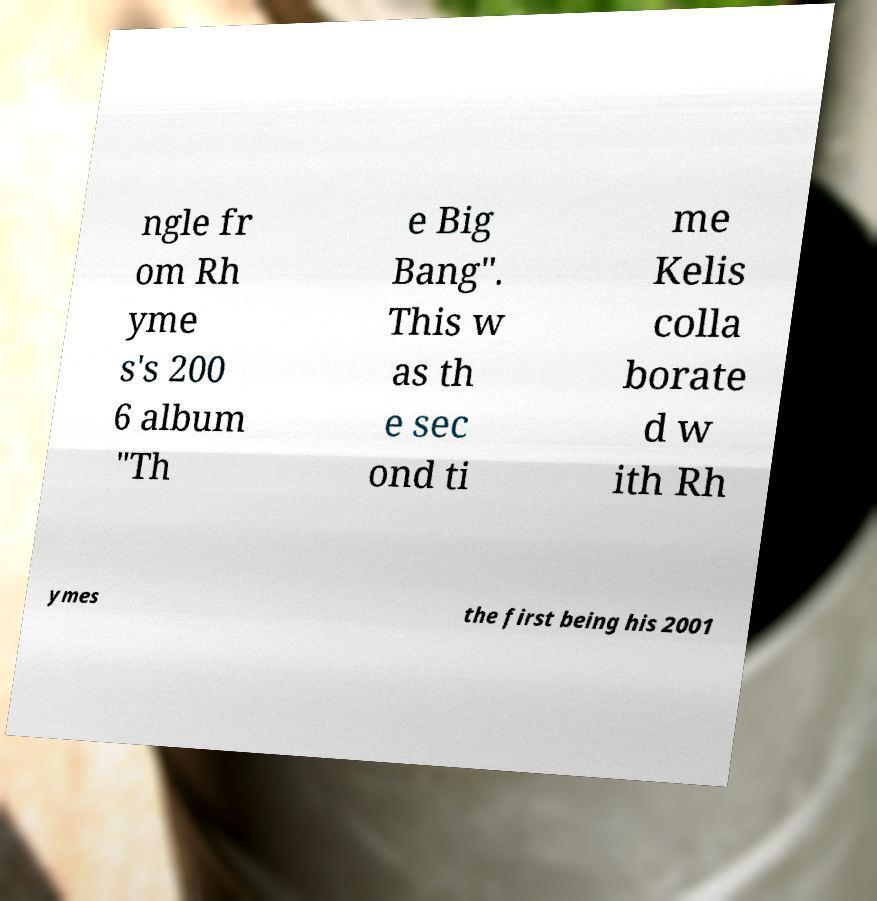What messages or text are displayed in this image? I need them in a readable, typed format. ngle fr om Rh yme s's 200 6 album "Th e Big Bang". This w as th e sec ond ti me Kelis colla borate d w ith Rh ymes the first being his 2001 